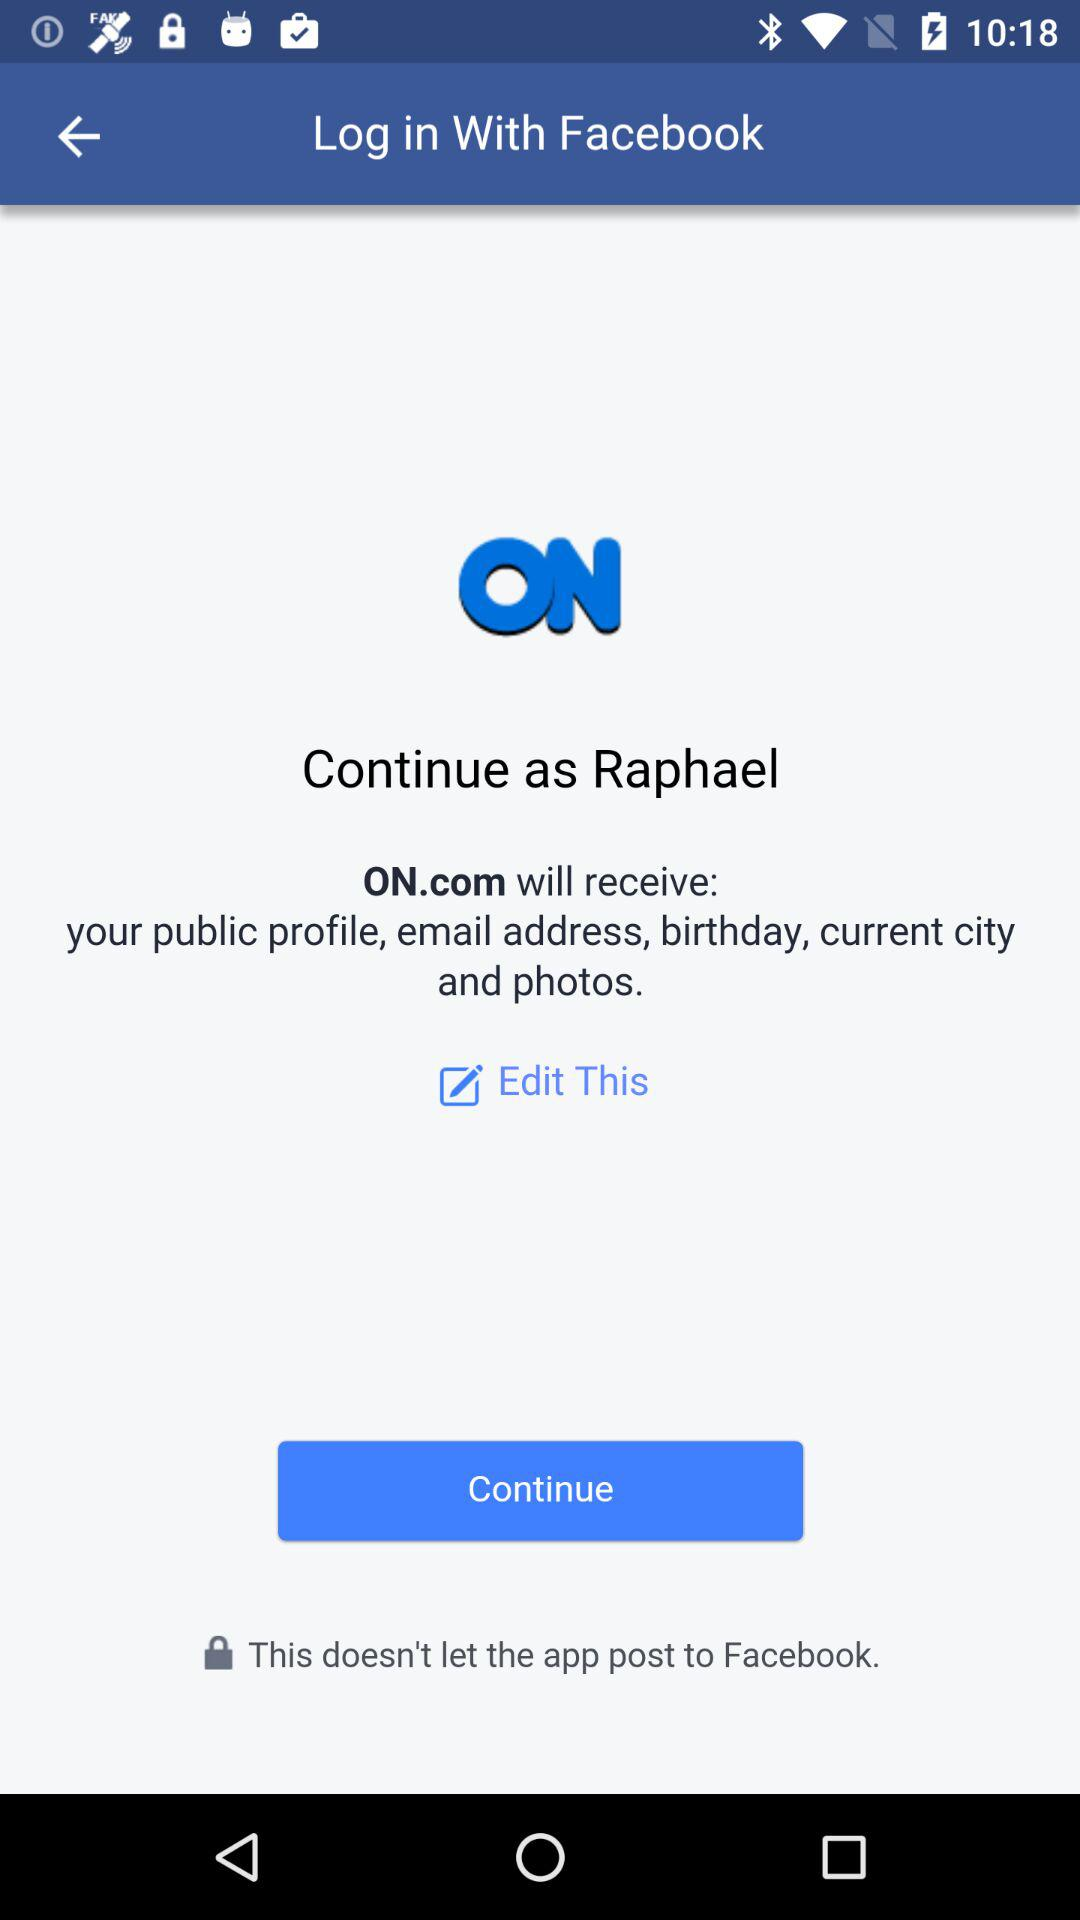What application is asking for permission? The application asking for permission is "ON.com". 